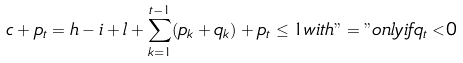Convert formula to latex. <formula><loc_0><loc_0><loc_500><loc_500>c + p _ { t } = h - i + l + \sum _ { k = 1 } ^ { t - 1 } ( p _ { k } + q _ { k } ) + p _ { t } \leq 1 w i t h " = " o n l y i f q _ { t } < 0</formula> 